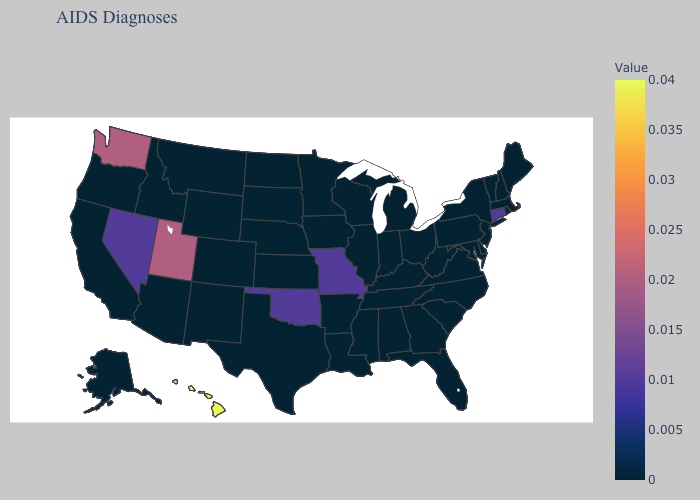Does North Carolina have the lowest value in the South?
Keep it brief. Yes. Does Washington have a lower value than Hawaii?
Quick response, please. Yes. Is the legend a continuous bar?
Quick response, please. Yes. Does Hawaii have the highest value in the USA?
Be succinct. Yes. 